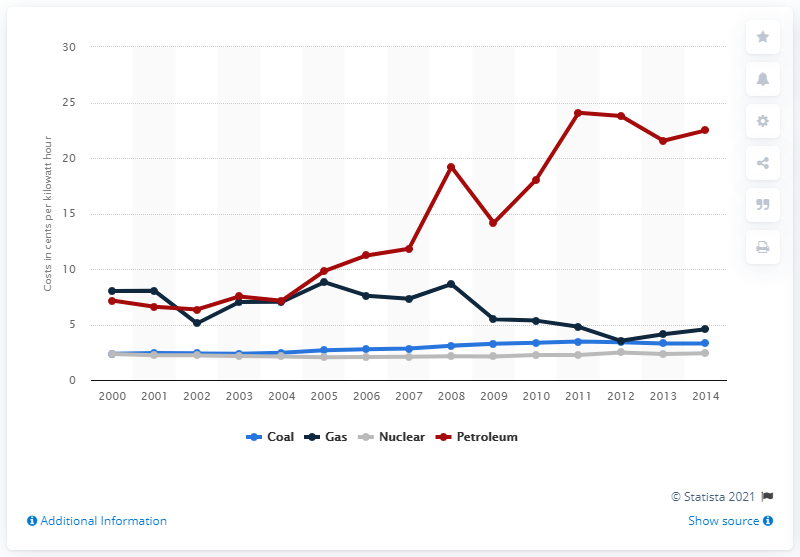Draw attention to some important aspects in this diagram. In 2014, the production cost of electricity generated from coal was 3.29 dollars per kilowatt hour. 